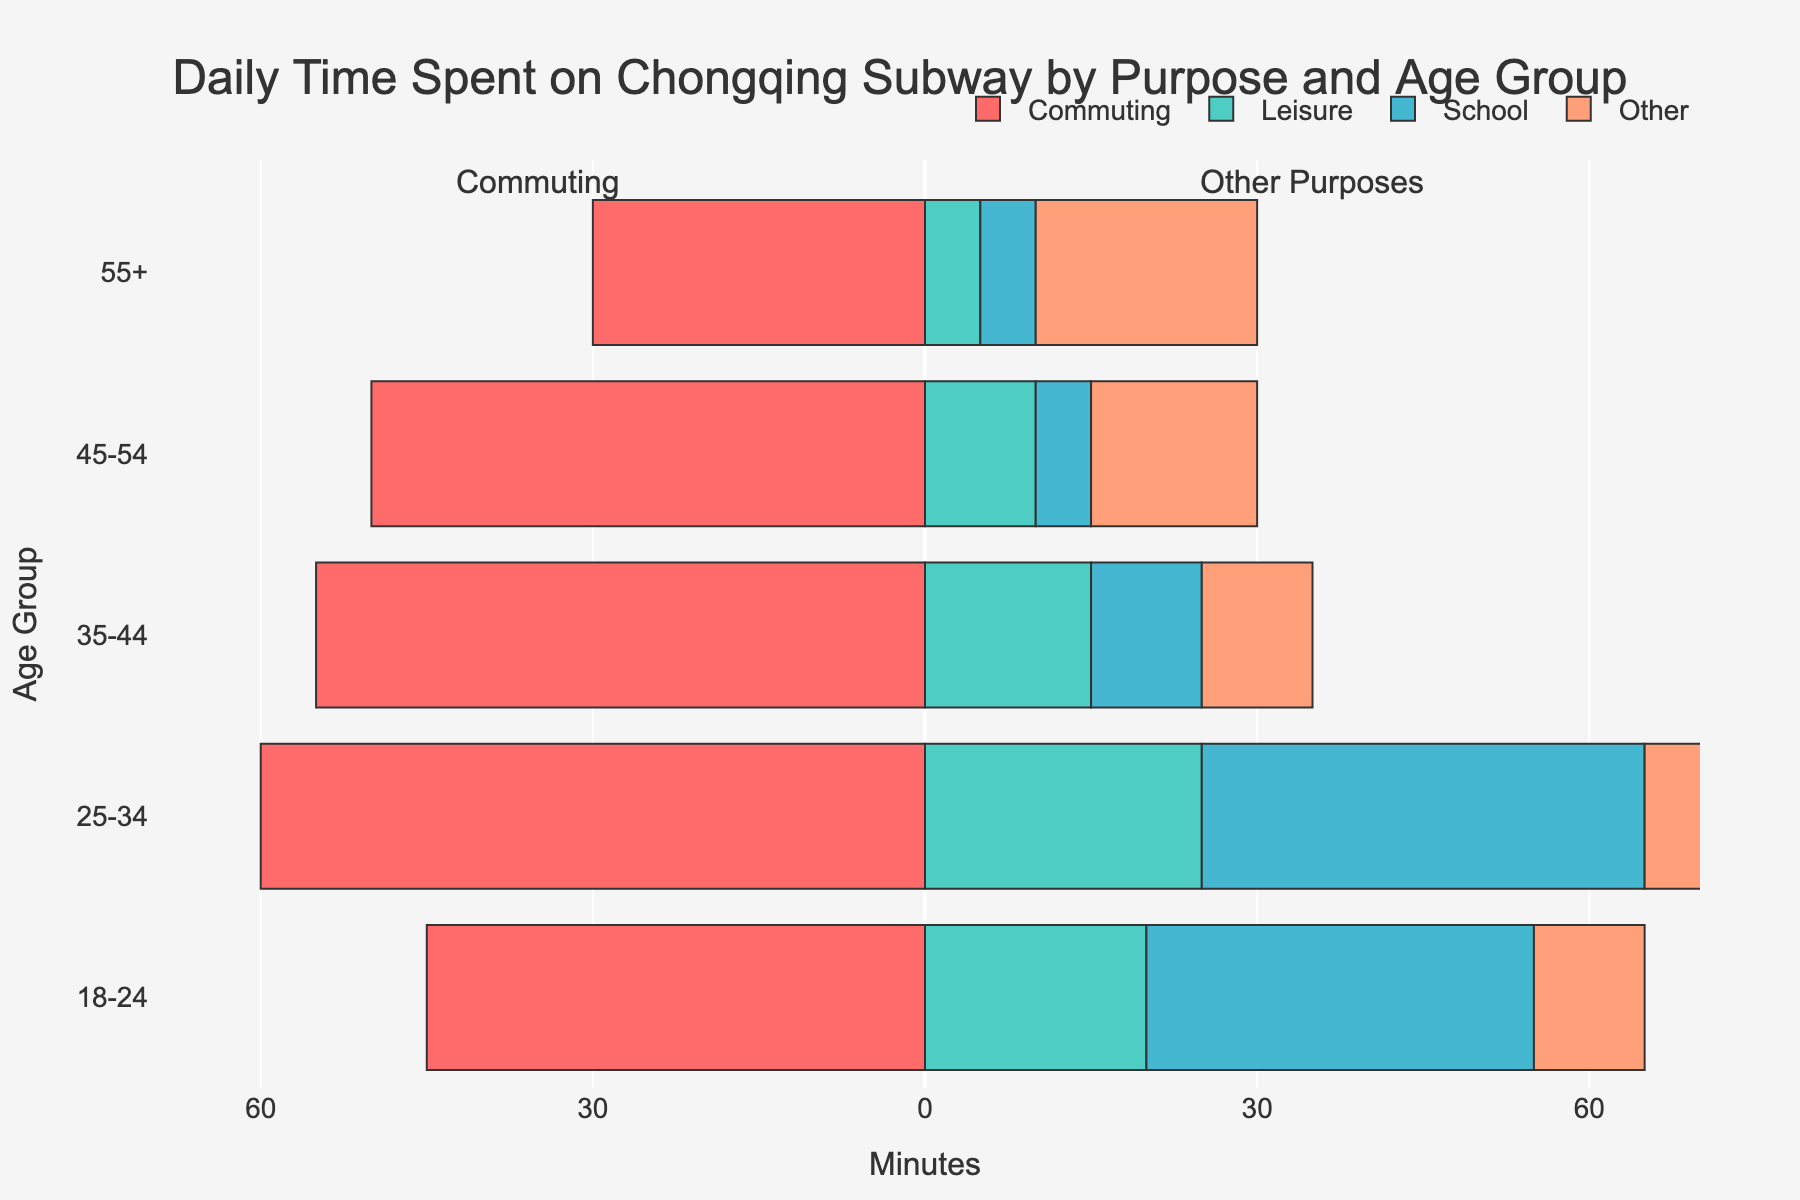Which age group spends the most time commuting daily? To find the age group that spends the most time commuting daily, we need to look at the bars colored in red representing commuting time. The age group 25-34 has the longest bar for commuting, with 60 minutes.
Answer: Age group 25-34 How much more time do residents in the 25-34 age group spend commuting compared to leisure purposes daily? The commuting time for the 25-34 age group is 60 minutes, while the leisure time is 25 minutes. The difference is 60 - 25 = 35 minutes.
Answer: 35 minutes Which age group spends the least time on leisure activities? To determine which age group spends the least time on leisure activities, we should look at the bars colored in green representing leisure time. The 55+ age group spends the least time, with 5 minutes.
Answer: Age group 55+ Compare the total time spent on school purposes by the 18-24 and 25-34 age groups. How much more does the latter spend? The 18-24 age group spends 35 minutes on school purposes, while the 25-34 age group spends 40 minutes. The difference is 40 - 35 = 5 minutes.
Answer: 5 minutes For the 18-24 age group, what is the total time spent on subway across all purposes? To get the total time, sum the minutes for commuting (45), leisure (20), school (35), and other (10). The calculation is 45 + 20 + 35 + 10 = 110 minutes.
Answer: 110 minutes Which purpose has the most significant difference in time across all age groups? To determine the purpose with the most considerable difference, we can visually compare the range of the bars' lengths for each purpose. Commuting (red) bars show the most variation, ranging from 60 minutes for 25-34 to 30 minutes for 55+.
Answer: Commuting What is the total time spent on the subway for the 45-54 age group? We need to sum the times for commuting (50), leisure (10), school (5), and other (15). The total is 50 + 10 + 5 + 15 = 80 minutes.
Answer: 80 minutes Compare the total time spent on leisure and other purposes by the 35-44 age group. Which one is higher and by how much? The leisure time for 35-44 is 15 minutes, and other purposes is 10 minutes. Leisure time is higher. The difference is 15 - 10 = 5 minutes.
Answer: Leisure by 5 minutes 